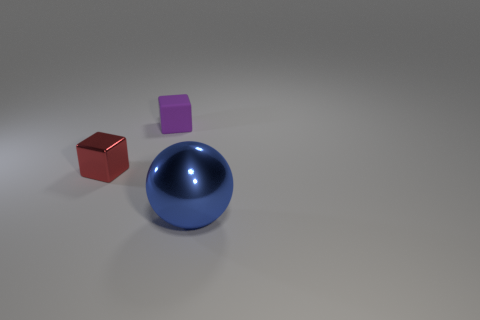Add 1 small gray metal cylinders. How many objects exist? 4 Subtract all red cubes. How many cubes are left? 1 Subtract all yellow balls. How many cyan cubes are left? 0 Subtract all blue metal spheres. Subtract all brown shiny cylinders. How many objects are left? 2 Add 3 tiny purple blocks. How many tiny purple blocks are left? 4 Add 2 large purple rubber spheres. How many large purple rubber spheres exist? 2 Subtract 0 green cubes. How many objects are left? 3 Subtract all blocks. How many objects are left? 1 Subtract 1 spheres. How many spheres are left? 0 Subtract all red balls. Subtract all gray blocks. How many balls are left? 1 